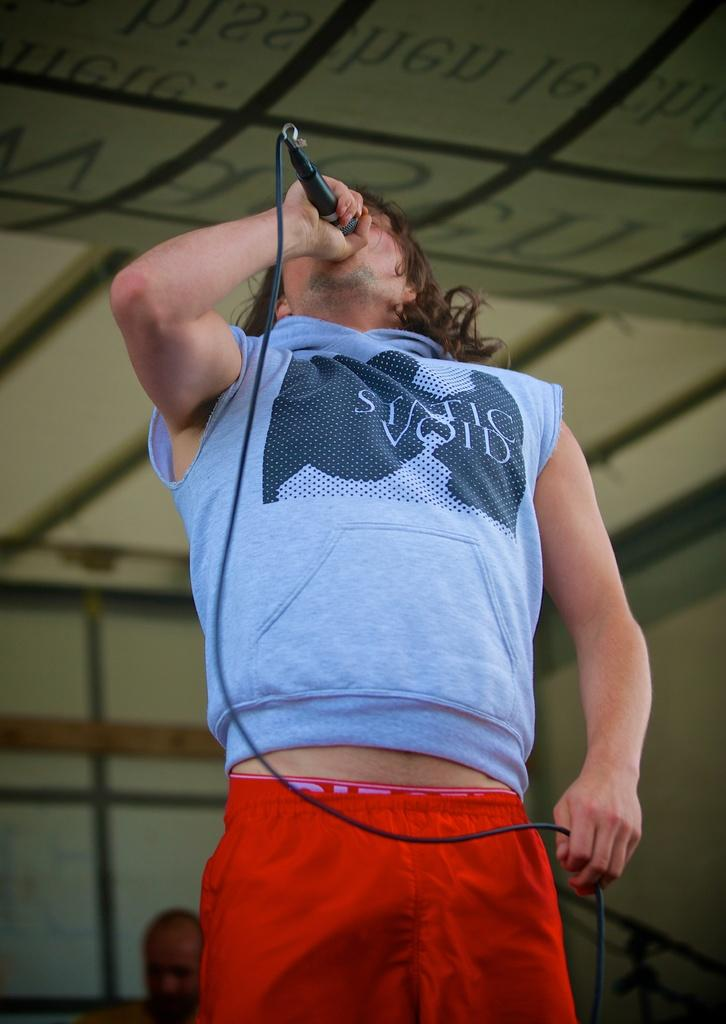<image>
Relay a brief, clear account of the picture shown. A singer wearing a blue shirt that says STATIC VOID. 